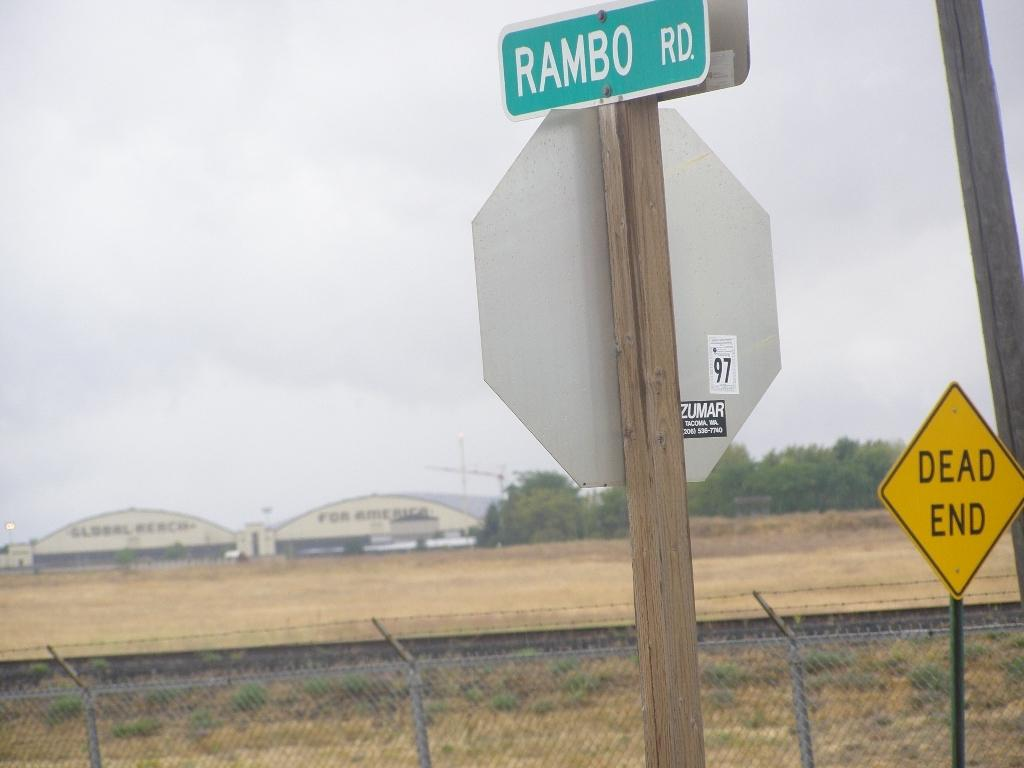<image>
Give a short and clear explanation of the subsequent image. A street sign that reads RAMBO RD. in a desolate area. 